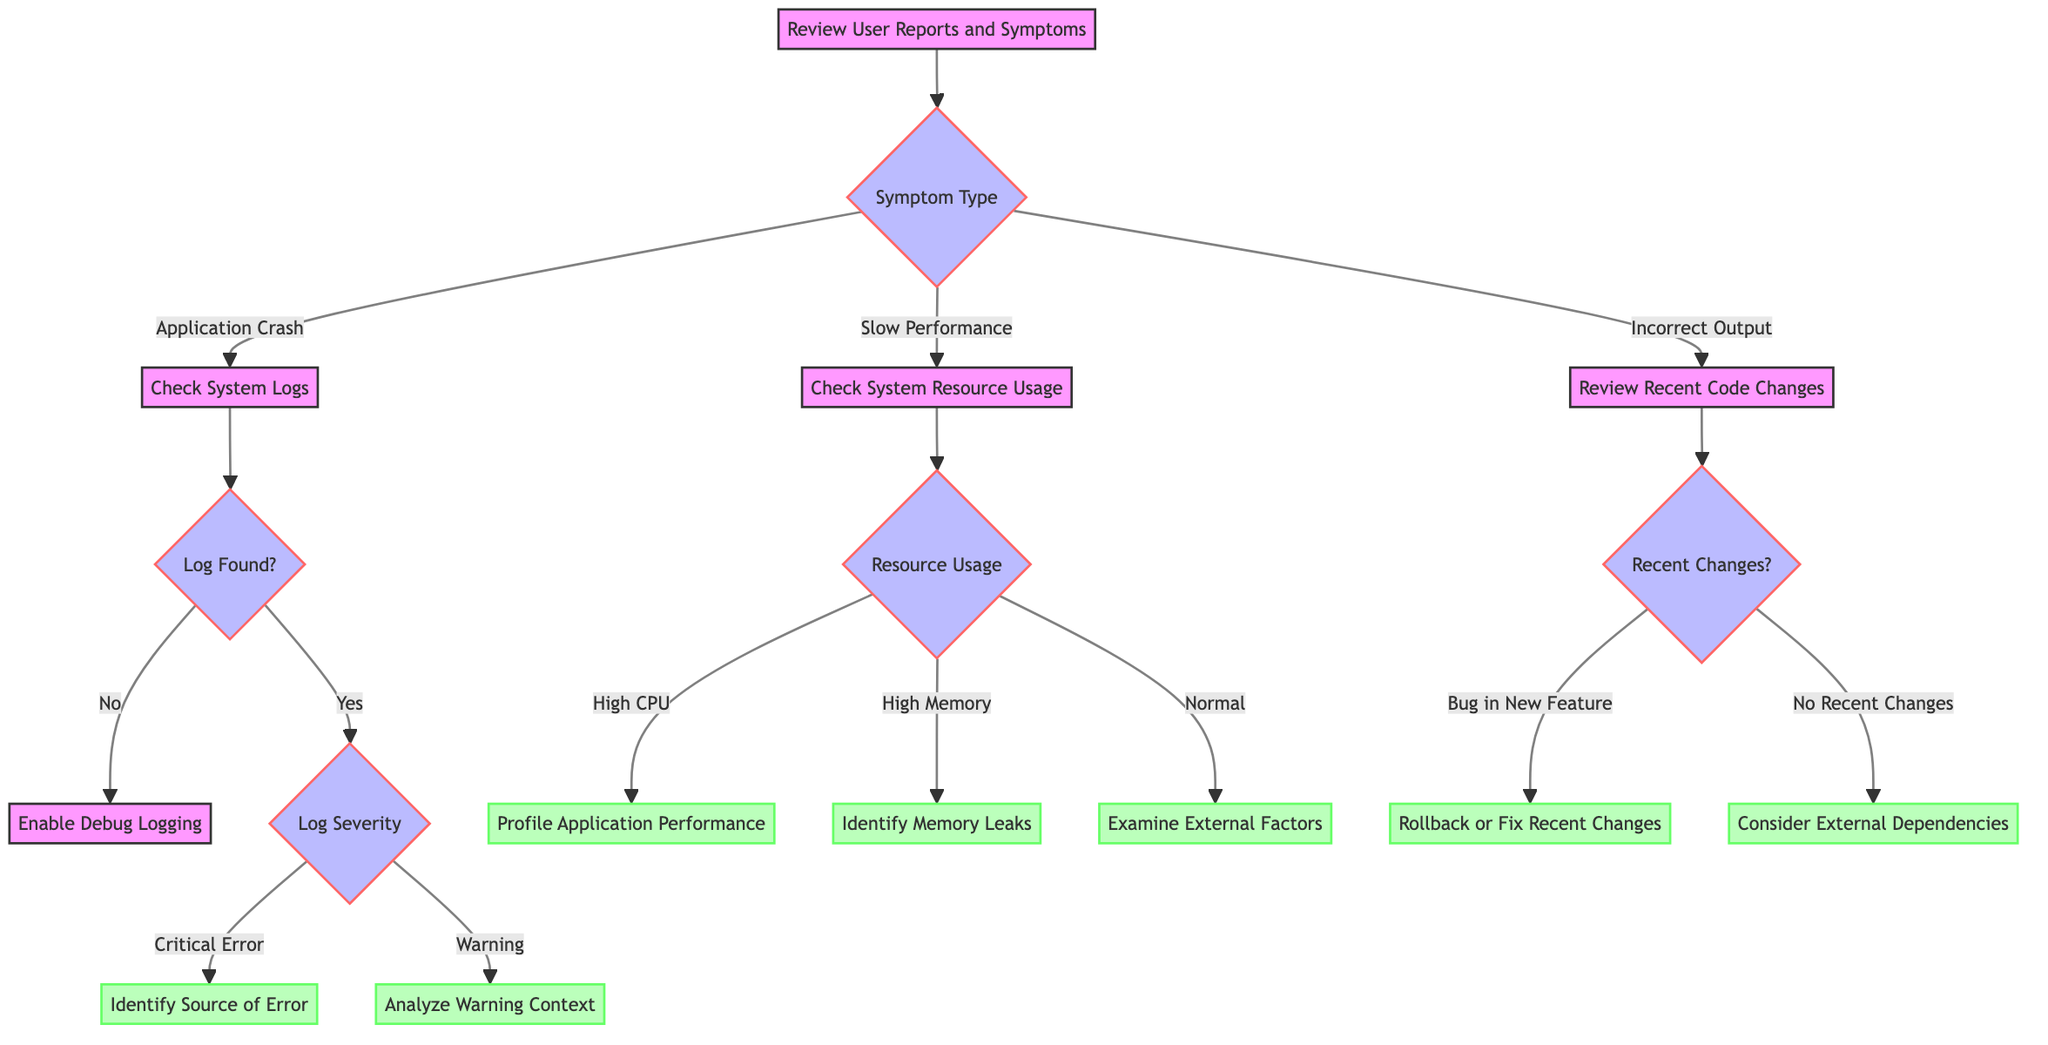What is the first step in diagnosing a software bug? The diagram indicates that the first step is to "Review User Reports and Symptoms." This is the root of the decision tree.
Answer: Review User Reports and Symptoms How many symptom types are there in the diagram? The diagram shows three distinct symptom types: Application Crash, Slow Performance, and Incorrect Output.
Answer: Three What should be done if logs are found and they contain critical errors? If logs are found and contain critical errors, the next step is to "Identify Source of Error," as indicated by the diagram flow.
Answer: Identify Source of Error If CPU usage is unusually high, what is the suggested next step? The diagram states that if CPU usage is high, the next step is to "Profile Application Performance," directing the user to investigate performance profiling.
Answer: Profile Application Performance What action should be taken if there are no recent code changes? According to the decision tree, if there are no recent code changes, the recommended action is to "Consider External Dependencies." This addresses unrelated potential causes of the issue.
Answer: Consider External Dependencies What happens after checking system logs if no logs are found? If no logs are found related to the crash, the next action to take is "Enable Debug Logging," prompting further investigation into logging settings.
Answer: Enable Debug Logging What is the decision after analyzing logs with warnings but no clear indication of failure? The diagram directs that if logs contain warnings but no clear indication of failure, the next step is to "Analyze Warning Context," suggesting a deeper review of the warning scenarios.
Answer: Analyze Warning Context What follows after identifying a bug in a new feature during recent code changes? The decision tree indicates that if a bug in a new feature is identified, the subsequent action is to "Rollback or Fix Recent Changes" to mitigate the issue caused by the new feature.
Answer: Rollback or Fix Recent Changes What are the next steps if memory usage is unusually high? The diagram suggests that if memory usage is high, the next action is to "Identify Memory Leaks," guiding the user to focus on memory evaluation.
Answer: Identify Memory Leaks 